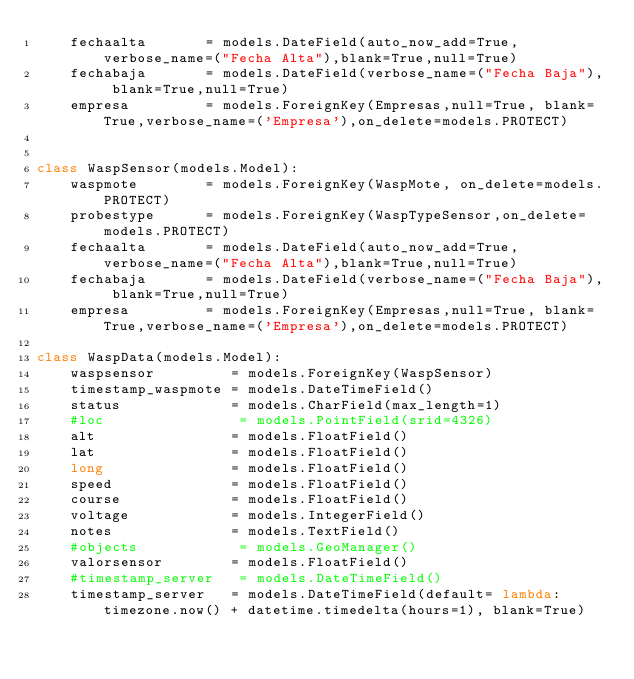<code> <loc_0><loc_0><loc_500><loc_500><_Python_>    fechaalta       = models.DateField(auto_now_add=True,verbose_name=("Fecha Alta"),blank=True,null=True)
    fechabaja       = models.DateField(verbose_name=("Fecha Baja"), blank=True,null=True)
    empresa         = models.ForeignKey(Empresas,null=True, blank=True,verbose_name=('Empresa'),on_delete=models.PROTECT)


class WaspSensor(models.Model):
    waspmote        = models.ForeignKey(WaspMote, on_delete=models.PROTECT)
    probestype      = models.ForeignKey(WaspTypeSensor,on_delete=models.PROTECT)
    fechaalta       = models.DateField(auto_now_add=True,verbose_name=("Fecha Alta"),blank=True,null=True)
    fechabaja       = models.DateField(verbose_name=("Fecha Baja"), blank=True,null=True)
    empresa         = models.ForeignKey(Empresas,null=True, blank=True,verbose_name=('Empresa'),on_delete=models.PROTECT)

class WaspData(models.Model):
    waspsensor         = models.ForeignKey(WaspSensor)
    timestamp_waspmote = models.DateTimeField()
    status             = models.CharField(max_length=1)
    #loc                = models.PointField(srid=4326)
    alt                = models.FloatField()
    lat                = models.FloatField()
    long               = models.FloatField()
    speed              = models.FloatField()
    course             = models.FloatField()
    voltage            = models.IntegerField()
    notes              = models.TextField()
    #objects            = models.GeoManager()
    valorsensor        = models.FloatField()
    #timestamp_server   = models.DateTimeField()
    timestamp_server   = models.DateTimeField(default= lambda: timezone.now() + datetime.timedelta(hours=1), blank=True)


</code> 